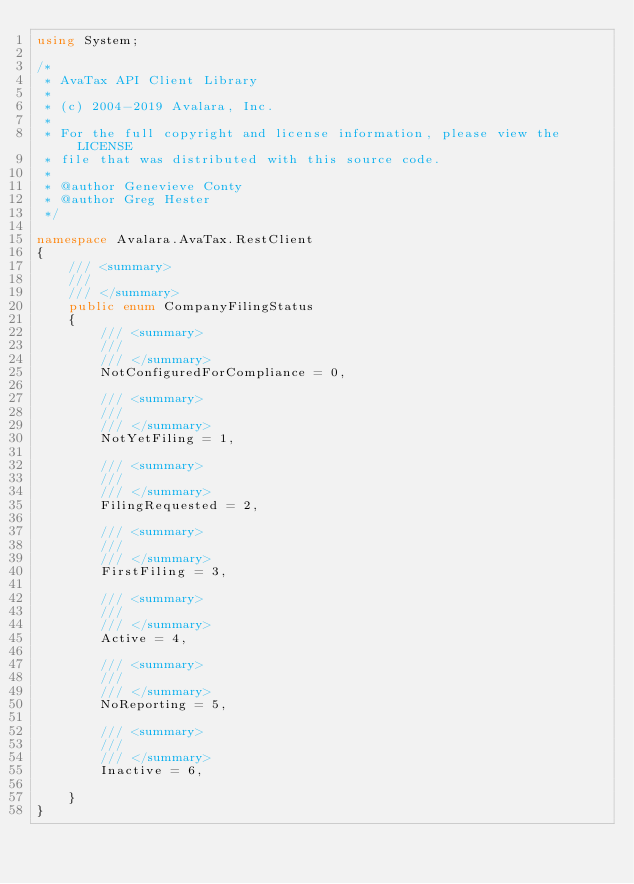<code> <loc_0><loc_0><loc_500><loc_500><_C#_>using System;

/*
 * AvaTax API Client Library
 *
 * (c) 2004-2019 Avalara, Inc.
 *
 * For the full copyright and license information, please view the LICENSE
 * file that was distributed with this source code.
 *
 * @author Genevieve Conty
 * @author Greg Hester
 */

namespace Avalara.AvaTax.RestClient
{
    /// <summary>
    /// 
    /// </summary>
    public enum CompanyFilingStatus
    {
        /// <summary>
        /// 
        /// </summary>
        NotConfiguredForCompliance = 0,

        /// <summary>
        /// 
        /// </summary>
        NotYetFiling = 1,

        /// <summary>
        /// 
        /// </summary>
        FilingRequested = 2,

        /// <summary>
        /// 
        /// </summary>
        FirstFiling = 3,

        /// <summary>
        /// 
        /// </summary>
        Active = 4,

        /// <summary>
        /// 
        /// </summary>
        NoReporting = 5,

        /// <summary>
        /// 
        /// </summary>
        Inactive = 6,

    }
}
</code> 